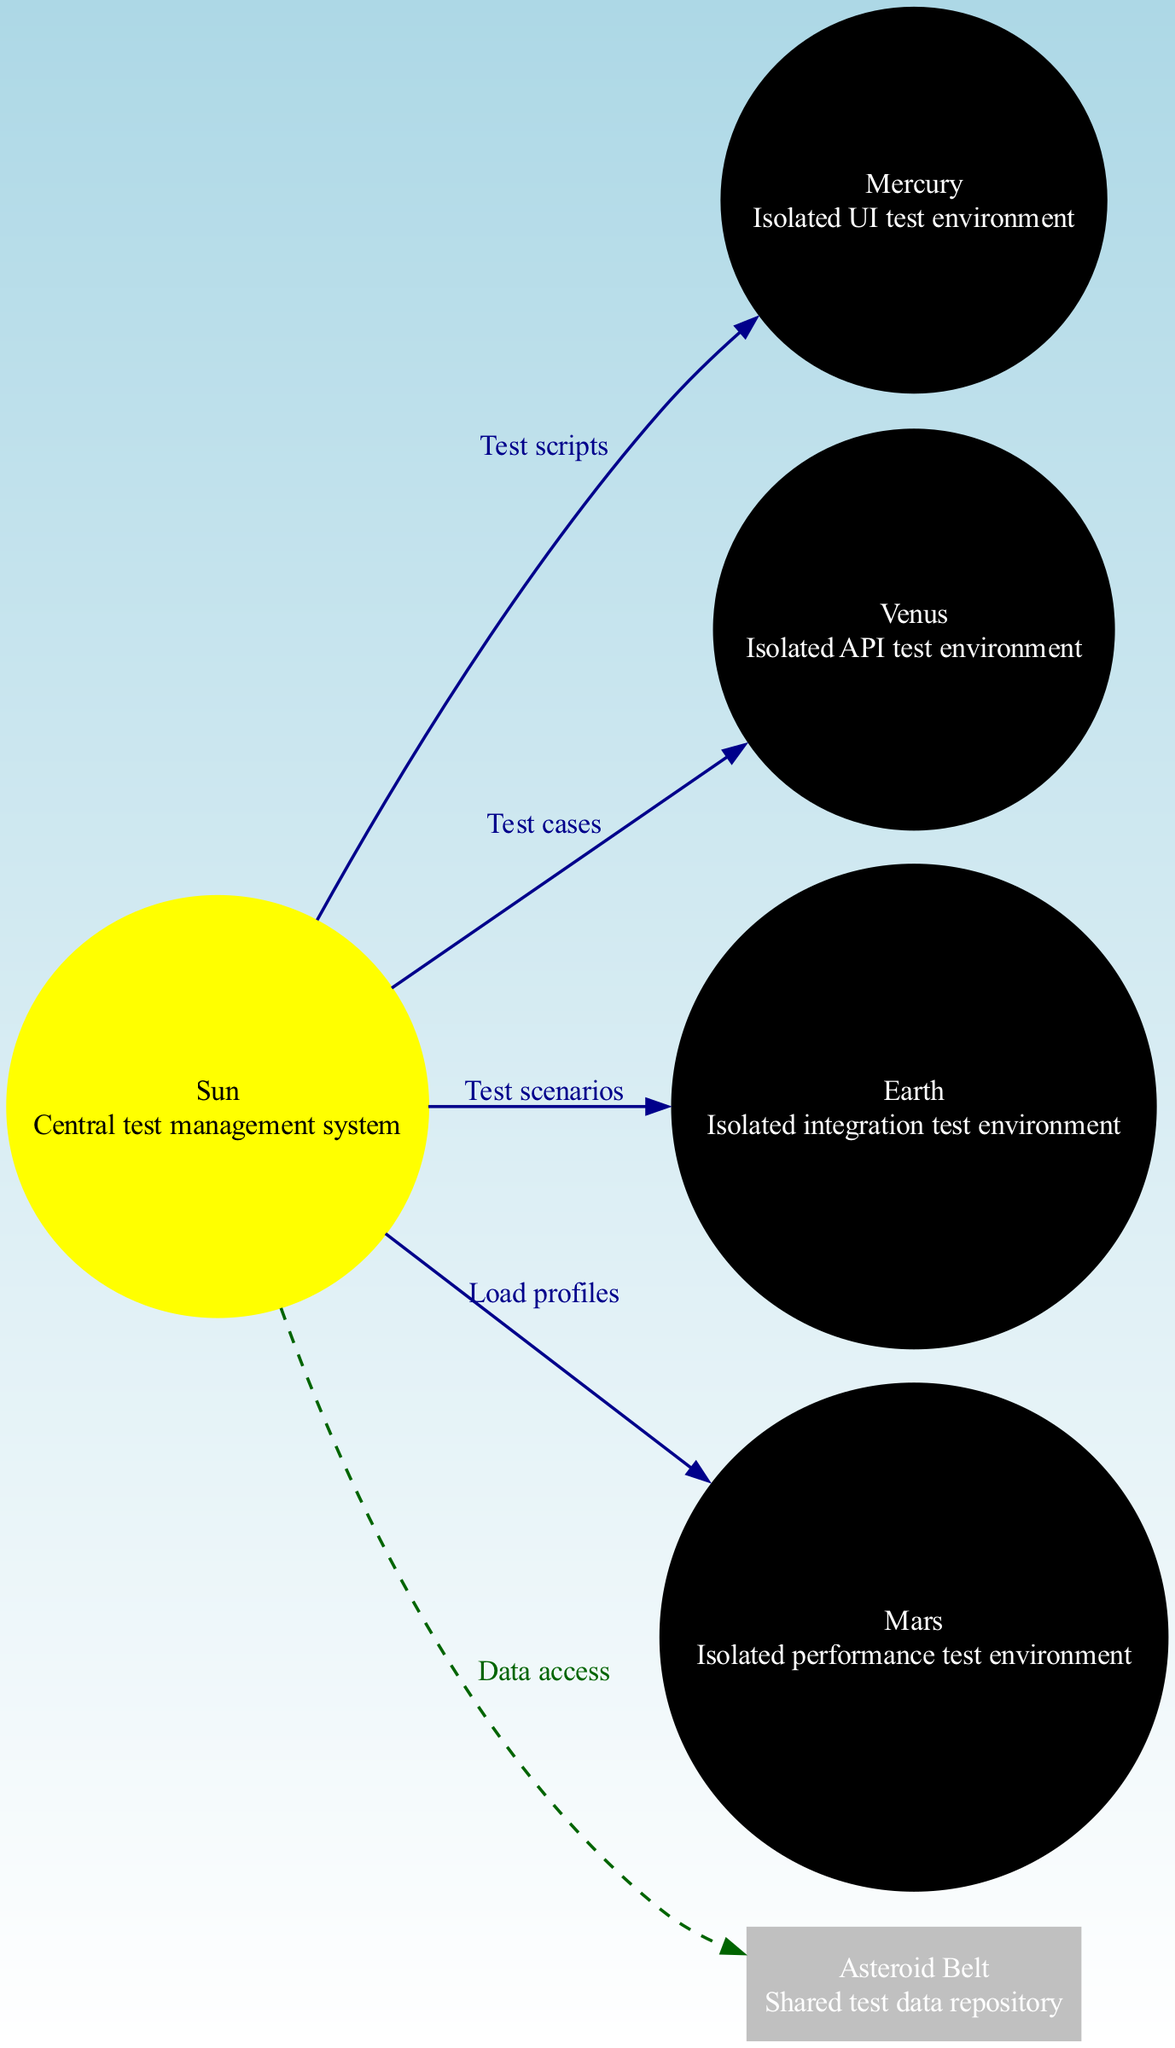What's the central body in the diagram? The central body in the diagram is represented as the "Sun," which is described as the central test management system.
Answer: Sun How many planets are present in the diagram? The diagram includes four planets: Mercury, Venus, Earth, and Mars. Counting these gives a total of four.
Answer: 4 What is the description of the Mercury node? The description of the Mercury node is provided as "Isolated UI test environment." This information is directly visible in the diagram.
Answer: Isolated UI test environment Which test environment is represented by Earth? Earth represents the "Isolated integration test environment," which is clearly labeled in the diagram.
Answer: Isolated integration test environment What do the connections from the Sun to Mercury represent? The connection from the Sun to Mercury is labeled "Test scripts," indicating that this line represents the association between the test management system and the UI test environment.
Answer: Test scripts Which two test environments share the "Asteroid Belt"? The "Asteroid Belt" is described as a "Shared test data repository," indicating that both API and integration test environments (Venus and Earth) utilize this shared resource.
Answer: API and integration test environments What is the function of the connection labeled "Load profiles"? The "Load profiles" connection labels the edge from the Sun to Mars, indicating a link between the central test management system and the isolated performance test environment.
Answer: Link to performance test environment What color is the node representing the Asteroid Belt in the diagram? The Asteroid Belt node is colored gray, which is specified by its properties in the diagram.
Answer: Gray How is the Asteroid Belt connected to the Sun? The connection to the Asteroid Belt from the Sun is depicted as a dashed line labeled "Data access," signifying a different kind of relationship compared to the other connections.
Answer: Dashed line labeled data access 